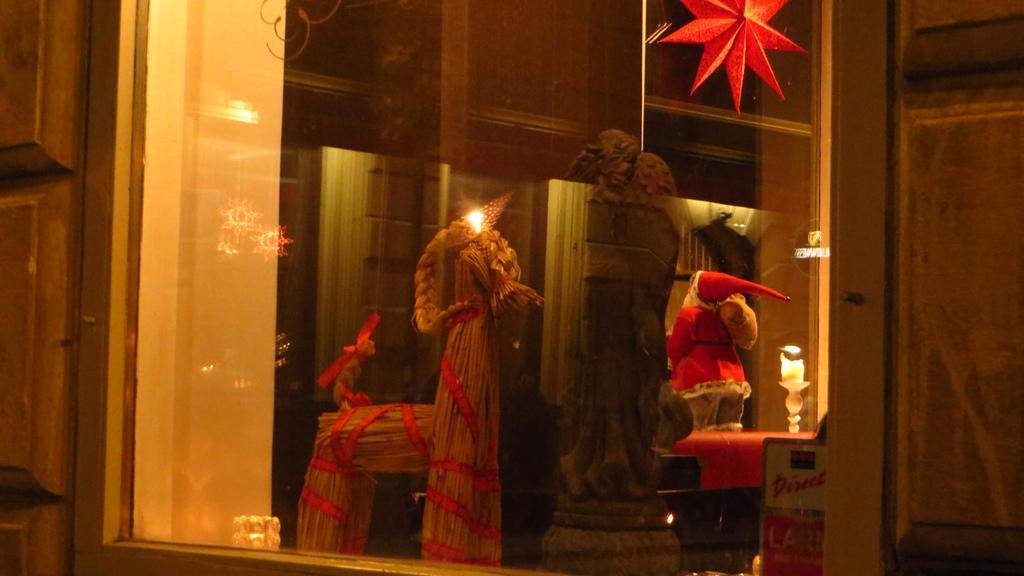Describe this image in one or two sentences. In this image in the front there is a glass. Behind the glass there is a statue and there is a table which is covered with a red colour cloth. On the table there is a lamp and there is a board with some text written on it. 